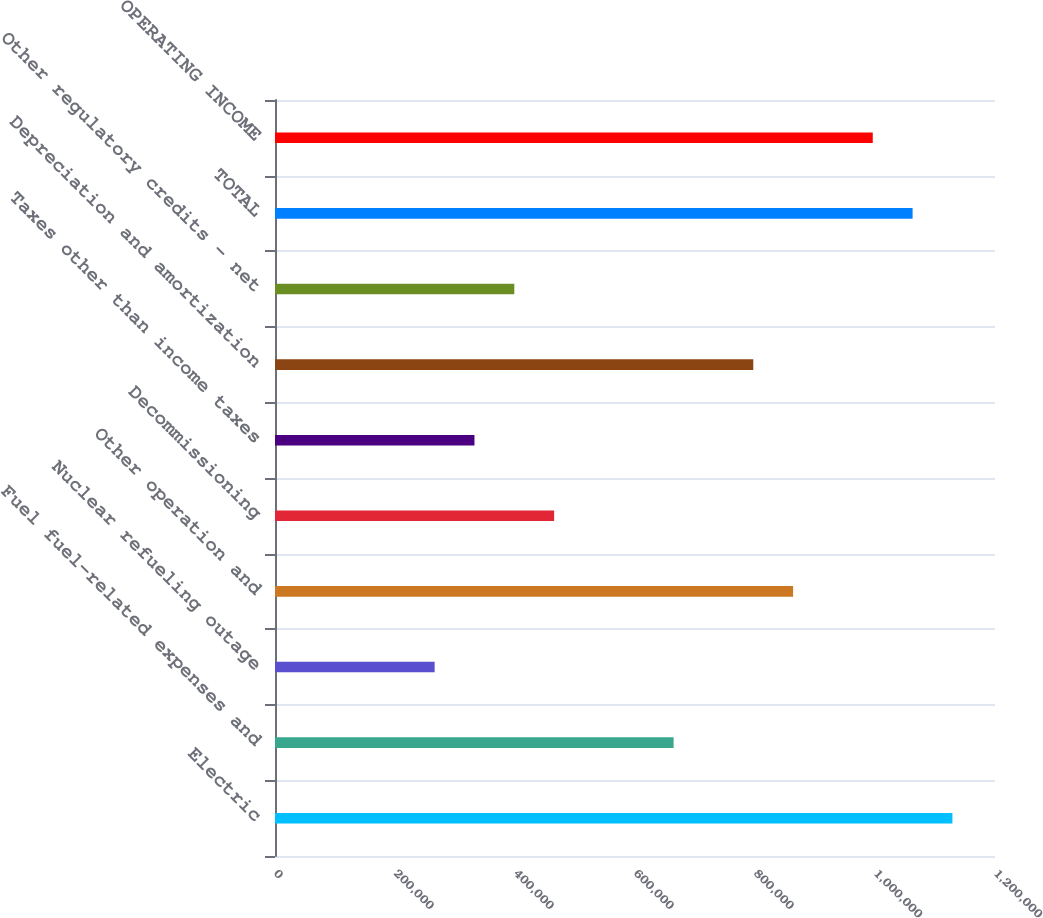Convert chart. <chart><loc_0><loc_0><loc_500><loc_500><bar_chart><fcel>Electric<fcel>Fuel fuel-related expenses and<fcel>Nuclear refueling outage<fcel>Other operation and<fcel>Decommissioning<fcel>Taxes other than income taxes<fcel>Depreciation and amortization<fcel>Other regulatory credits - net<fcel>TOTAL<fcel>OPERATING INCOME<nl><fcel>1.12905e+06<fcel>664364<fcel>266063<fcel>863514<fcel>465214<fcel>332446<fcel>797131<fcel>398830<fcel>1.06266e+06<fcel>996282<nl></chart> 